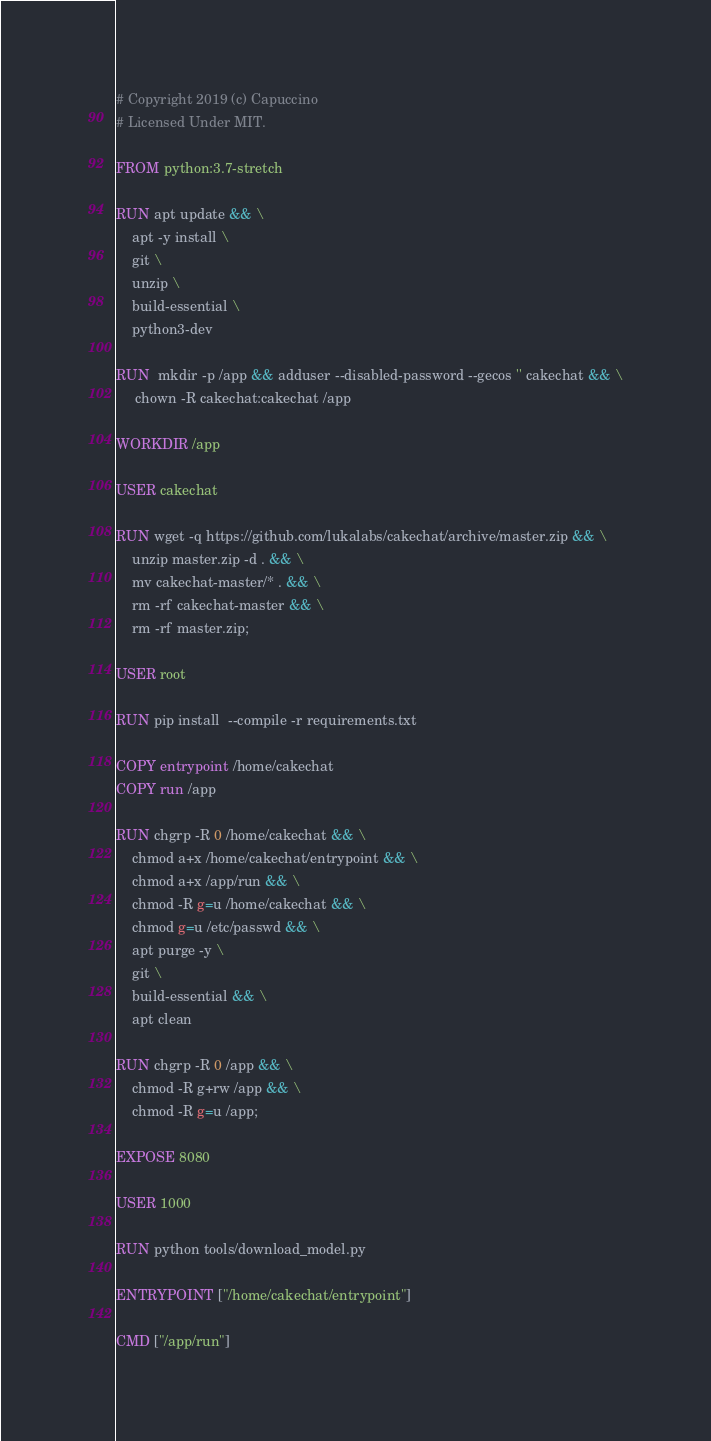Convert code to text. <code><loc_0><loc_0><loc_500><loc_500><_Dockerfile_># Copyright 2019 (c) Capuccino
# Licensed Under MIT.

FROM python:3.7-stretch

RUN apt update && \
    apt -y install \
    git \
    unzip \
    build-essential \
    python3-dev 

RUN  mkdir -p /app && adduser --disabled-password --gecos '' cakechat && \
     chown -R cakechat:cakechat /app

WORKDIR /app

USER cakechat

RUN wget -q https://github.com/lukalabs/cakechat/archive/master.zip && \
    unzip master.zip -d . && \
    mv cakechat-master/* . && \
    rm -rf cakechat-master && \
    rm -rf master.zip;

USER root

RUN pip install  --compile -r requirements.txt

COPY entrypoint /home/cakechat
COPY run /app

RUN chgrp -R 0 /home/cakechat && \
    chmod a+x /home/cakechat/entrypoint && \
    chmod a+x /app/run && \
    chmod -R g=u /home/cakechat && \
    chmod g=u /etc/passwd && \
    apt purge -y \
    git \
    build-essential && \
    apt clean

RUN chgrp -R 0 /app && \
    chmod -R g+rw /app && \
    chmod -R g=u /app;

EXPOSE 8080

USER 1000

RUN python tools/download_model.py

ENTRYPOINT ["/home/cakechat/entrypoint"]

CMD ["/app/run"]</code> 